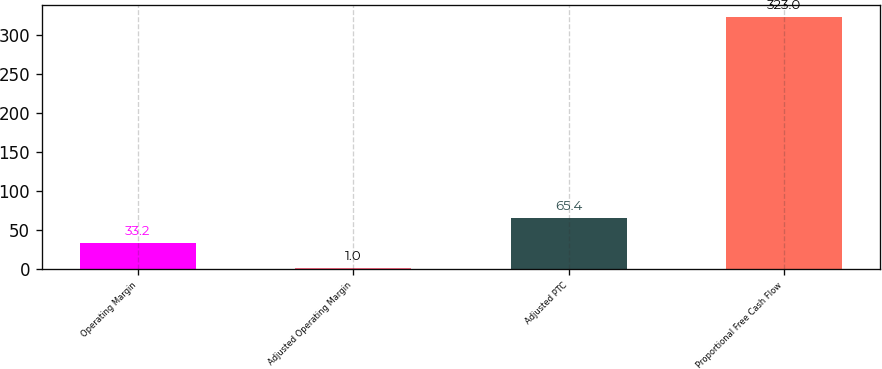Convert chart to OTSL. <chart><loc_0><loc_0><loc_500><loc_500><bar_chart><fcel>Operating Margin<fcel>Adjusted Operating Margin<fcel>Adjusted PTC<fcel>Proportional Free Cash Flow<nl><fcel>33.2<fcel>1<fcel>65.4<fcel>323<nl></chart> 